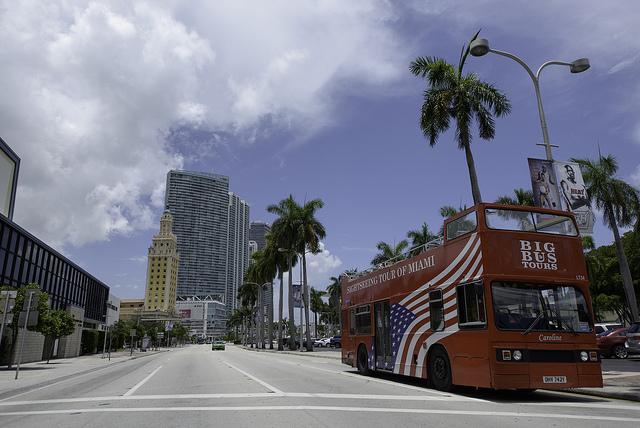What is the purpose of this traffic stop?
Concise answer only. Intersection. Is there any shade from the sun?
Concise answer only. No. What time is it?
Concise answer only. Noon. What is the name of the road?
Answer briefly. International blvd. What is this state's national bird?
Give a very brief answer. Eagle. Is this a dead-end street?
Keep it brief. No. How many buses do you see?
Be succinct. 1. What flag is on the bus?
Short answer required. Usa. What color is the bus?
Answer briefly. Red. What logo is on the wall on the right side of the screen?
Short answer required. Flag. What is the color of the bus?
Concise answer only. Red. Do you see a woman walking in the middle of the street?
Answer briefly. No. What country's flag is in this photo?
Write a very short answer. Usa. What trees are here?
Keep it brief. Palm. What color stripe is on the bus?
Keep it brief. White. What is the name of the tall tower in the back of the image?
Keep it brief. Skyscraper. 